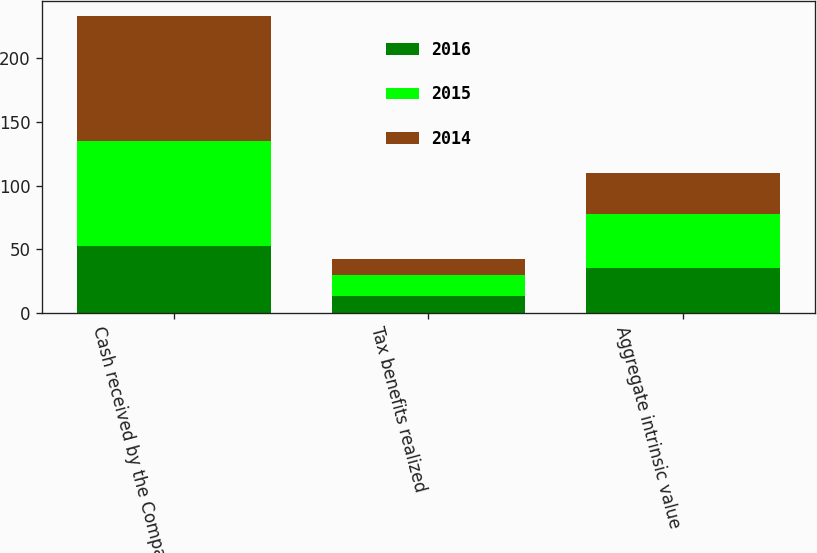Convert chart. <chart><loc_0><loc_0><loc_500><loc_500><stacked_bar_chart><ecel><fcel>Cash received by the Company<fcel>Tax benefits realized<fcel>Aggregate intrinsic value<nl><fcel>2016<fcel>52.6<fcel>13.6<fcel>35.5<nl><fcel>2015<fcel>82.6<fcel>16.2<fcel>42.2<nl><fcel>2014<fcel>98.5<fcel>12.3<fcel>32.1<nl></chart> 